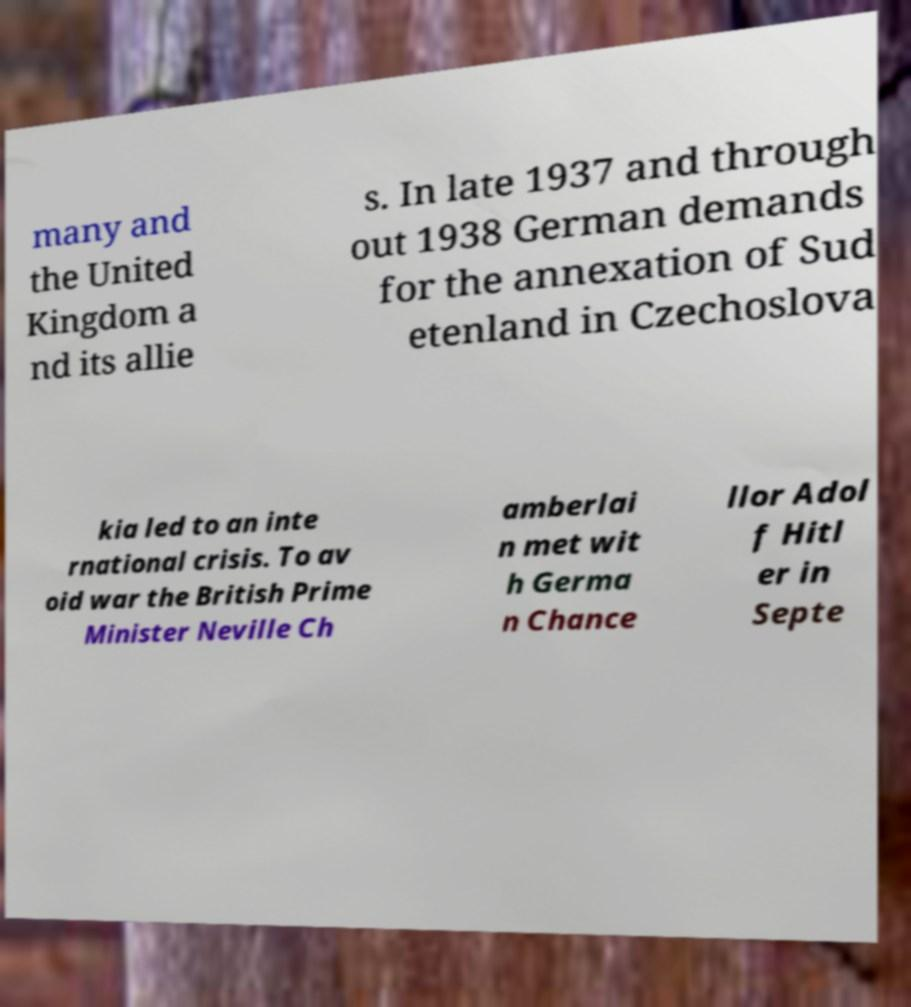Can you read and provide the text displayed in the image?This photo seems to have some interesting text. Can you extract and type it out for me? many and the United Kingdom a nd its allie s. In late 1937 and through out 1938 German demands for the annexation of Sud etenland in Czechoslova kia led to an inte rnational crisis. To av oid war the British Prime Minister Neville Ch amberlai n met wit h Germa n Chance llor Adol f Hitl er in Septe 